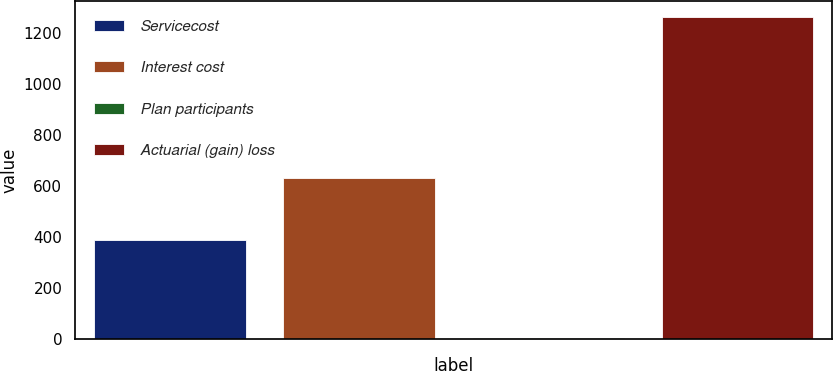Convert chart to OTSL. <chart><loc_0><loc_0><loc_500><loc_500><bar_chart><fcel>Servicecost<fcel>Interest cost<fcel>Plan participants<fcel>Actuarial (gain) loss<nl><fcel>388<fcel>628<fcel>1<fcel>1260<nl></chart> 